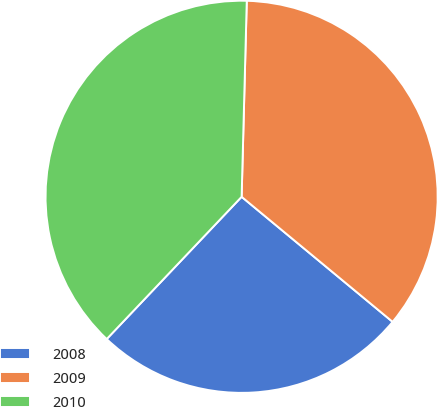<chart> <loc_0><loc_0><loc_500><loc_500><pie_chart><fcel>2008<fcel>2009<fcel>2010<nl><fcel>26.07%<fcel>35.59%<fcel>38.34%<nl></chart> 